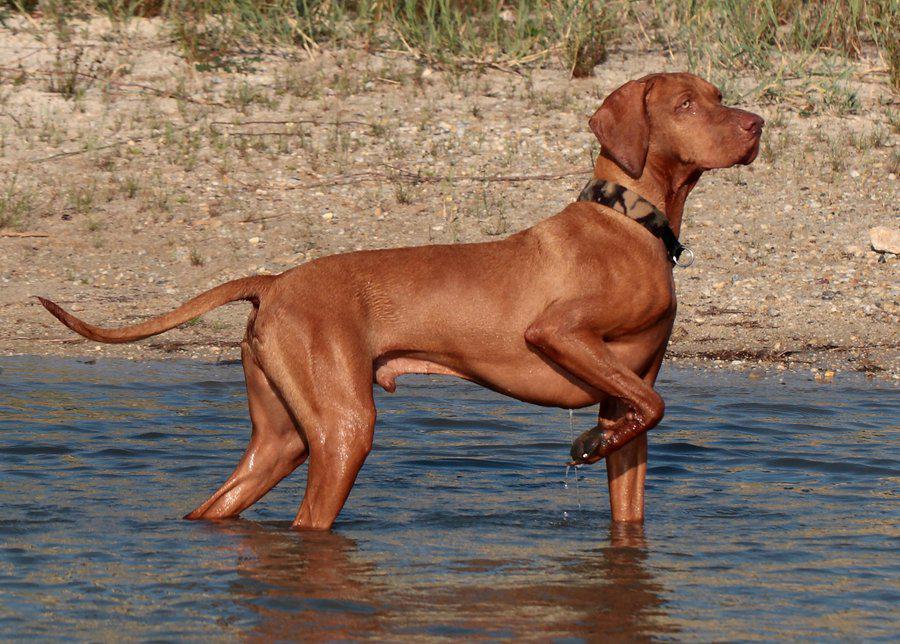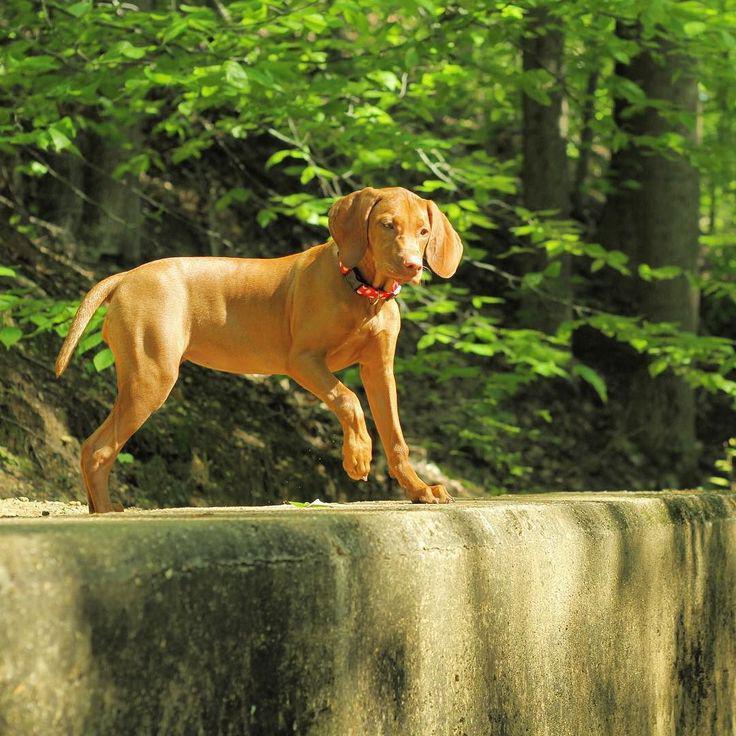The first image is the image on the left, the second image is the image on the right. Analyze the images presented: Is the assertion "In one image a dog is standing with one front leg raised up and its tail extended behind it." valid? Answer yes or no. Yes. The first image is the image on the left, the second image is the image on the right. For the images shown, is this caption "One image shows a red-orange dog standing in profile with its head upright, tail outstretched, and a front paw raised and bent inward." true? Answer yes or no. Yes. 